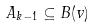<formula> <loc_0><loc_0><loc_500><loc_500>A _ { k - 1 } \subseteq B ( v )</formula> 